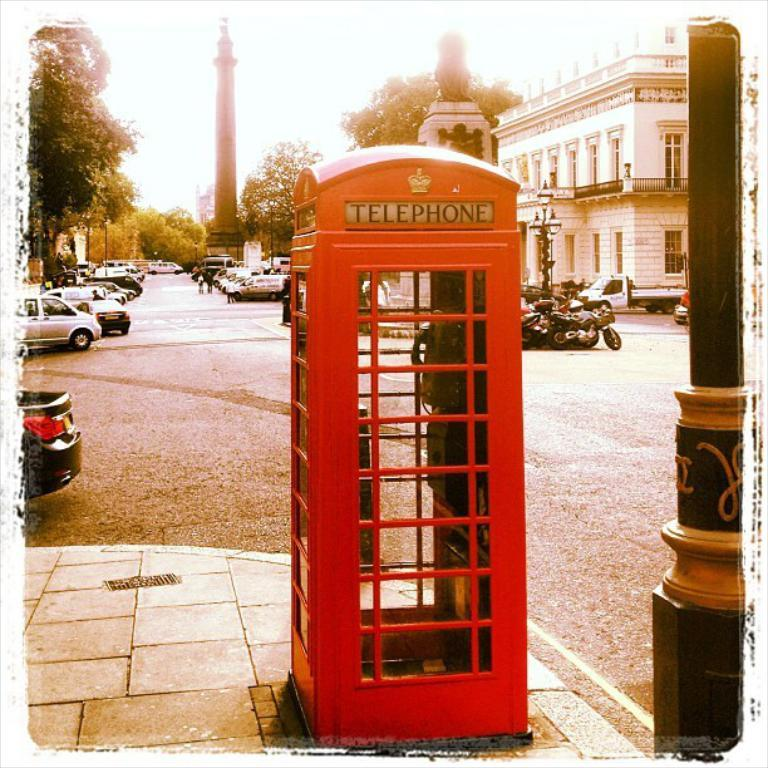<image>
Relay a brief, clear account of the picture shown. A red phone booth that reads TELEPHONE on it is shown on the street corner. 